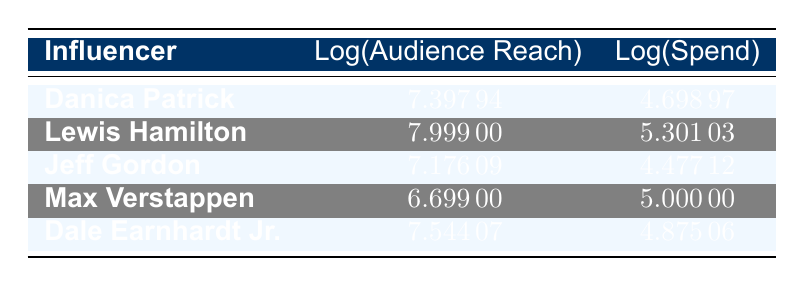What is the logarithmic value of audience reach for Lewis Hamilton? The table shows the logarithmic audience reach for each influencer. For Lewis Hamilton, the value is directly listed as 7.99900.
Answer: 7.99900 What is the spend on the campaign for Dale Earnhardt Jr.? The table lists the spend for each influencer. For Dale Earnhardt Jr., the spend is listed as 75000.
Answer: 75000 Which influencer has the highest logarithmic audience reach? By comparing the logarithmic audience reach values in the table, Lewis Hamilton has the highest value at 7.99900.
Answer: Lewis Hamilton What is the difference between the logarithmic spend of Danica Patrick and Max Verstappen? The logarithmic spend for Danica Patrick is 4.69897, and for Max Verstappen, it is 5.00000. The difference is calculated as 5.00000 - 4.69897 = 0.30103.
Answer: 0.30103 Is Jeff Gordon's logarithmic audience reach greater than that of Dale Earnhardt Jr.? The logarithmic audience reach for Jeff Gordon is 7.17609, while for Dale Earnhardt Jr. it is 7.54407. Since 7.17609 is less than 7.54407, the answer is false.
Answer: No What is the average logarithmic spend of all influencers listed in the table? First, sum the logarithmic spend values: 4.69897 + 5.30103 + 4.47712 + 5.00000 + 4.87506 = 24.35218. There are 5 influencers, so the average is 24.35218 / 5 = 4.87044.
Answer: 4.87044 Does Max Verstappen have a higher audience reach than Jeff Gordon? Max Verstappen has an audience reach of 5000000 while Jeff Gordon has an audience reach of 1500000. Since 5000000 is greater than 1500000, the statement is true.
Answer: Yes What is the sum of the logarithmic audience reach values for Danica Patrick and Dale Earnhardt Jr.? The values for Danica Patrick and Dale Earnhardt Jr. are 7.39794 and 7.54407, respectively. The sum is calculated as 7.39794 + 7.54407 = 14.94201.
Answer: 14.94201 